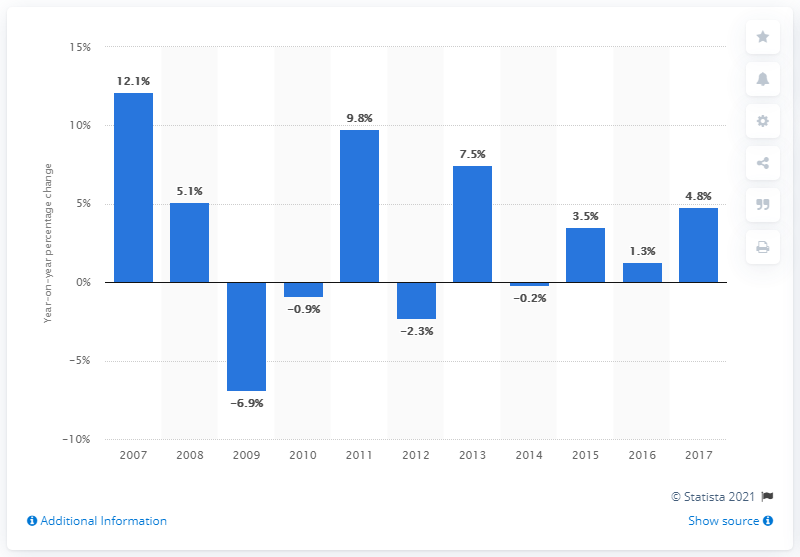Identify some key points in this picture. The turnover increased by 1.3% in 2016. In 2017, the turnover experienced a positive percentage change of 4.8%. 